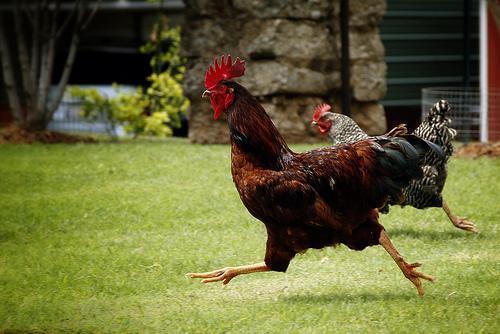How many chicken running?
Give a very brief answer. 2. 